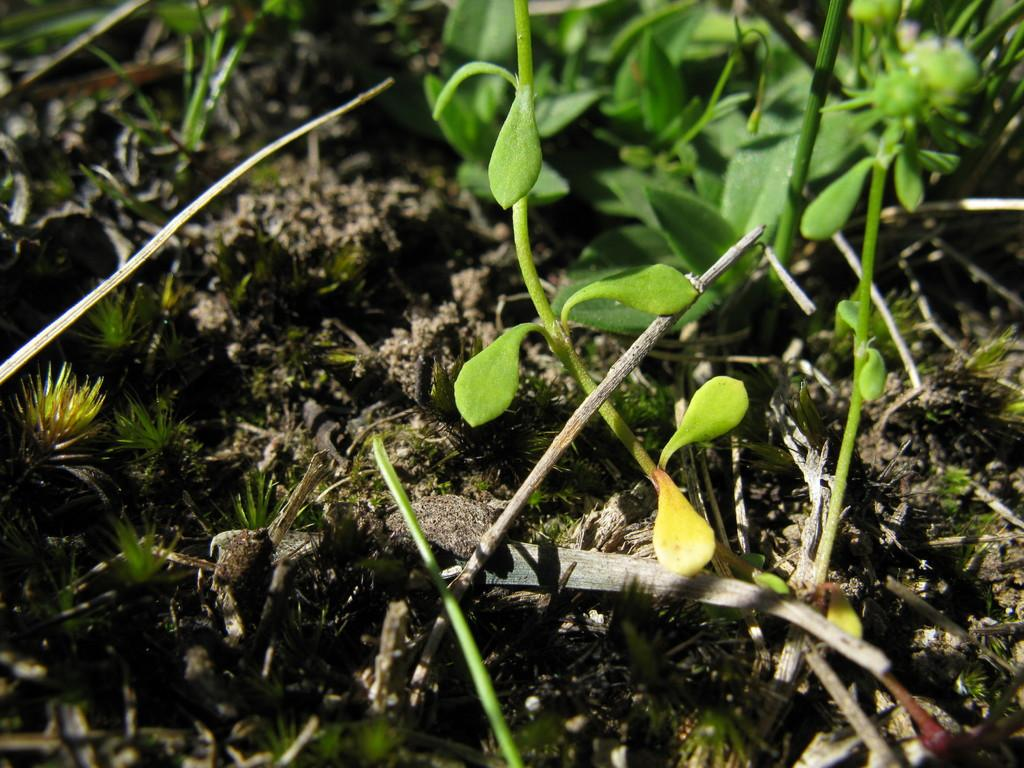What is the color of the ground in the image? The ground in the image is brown in color. What type of living organisms can be seen in the image? There are plants in the image. What colors are the plants in the image? The plants are green and yellow in color. Can you see any fangs on the plants in the image? There are no fangs present on the plants in the image, as plants do not have fangs. 